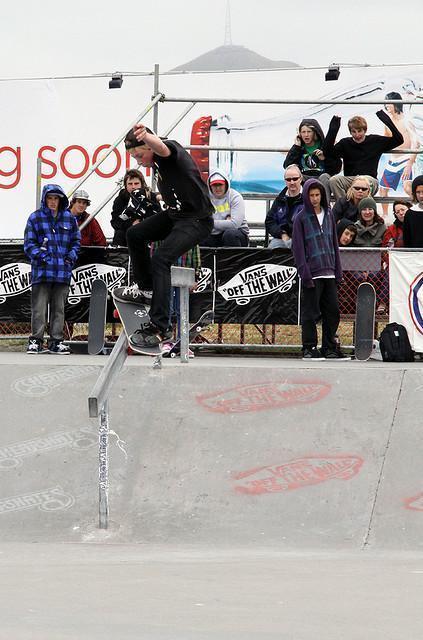What is he doing hanging from the board?
Select the accurate answer and provide explanation: 'Answer: answer
Rationale: rationale.'
Options: Jumping, falling, balancing, bouncing. Answer: balancing.
Rationale: A person is on a skateboard performing a jump. people have to balance on skateboards to avoid falling. 